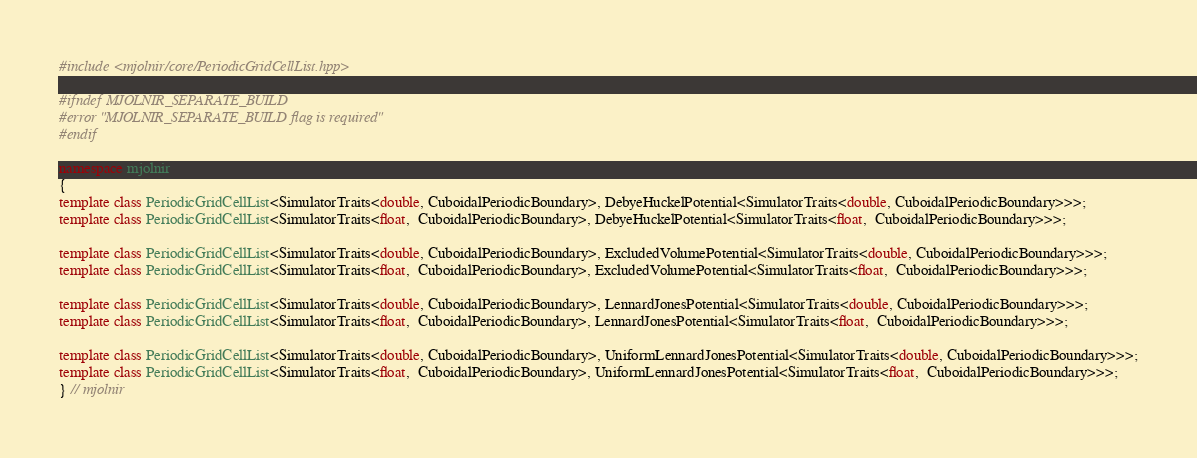<code> <loc_0><loc_0><loc_500><loc_500><_C++_>#include <mjolnir/core/PeriodicGridCellList.hpp>

#ifndef MJOLNIR_SEPARATE_BUILD
#error "MJOLNIR_SEPARATE_BUILD flag is required"
#endif

namespace mjolnir
{
template class PeriodicGridCellList<SimulatorTraits<double, CuboidalPeriodicBoundary>, DebyeHuckelPotential<SimulatorTraits<double, CuboidalPeriodicBoundary>>>;
template class PeriodicGridCellList<SimulatorTraits<float,  CuboidalPeriodicBoundary>, DebyeHuckelPotential<SimulatorTraits<float,  CuboidalPeriodicBoundary>>>;

template class PeriodicGridCellList<SimulatorTraits<double, CuboidalPeriodicBoundary>, ExcludedVolumePotential<SimulatorTraits<double, CuboidalPeriodicBoundary>>>;
template class PeriodicGridCellList<SimulatorTraits<float,  CuboidalPeriodicBoundary>, ExcludedVolumePotential<SimulatorTraits<float,  CuboidalPeriodicBoundary>>>;

template class PeriodicGridCellList<SimulatorTraits<double, CuboidalPeriodicBoundary>, LennardJonesPotential<SimulatorTraits<double, CuboidalPeriodicBoundary>>>;
template class PeriodicGridCellList<SimulatorTraits<float,  CuboidalPeriodicBoundary>, LennardJonesPotential<SimulatorTraits<float,  CuboidalPeriodicBoundary>>>;

template class PeriodicGridCellList<SimulatorTraits<double, CuboidalPeriodicBoundary>, UniformLennardJonesPotential<SimulatorTraits<double, CuboidalPeriodicBoundary>>>;
template class PeriodicGridCellList<SimulatorTraits<float,  CuboidalPeriodicBoundary>, UniformLennardJonesPotential<SimulatorTraits<float,  CuboidalPeriodicBoundary>>>;
} // mjolnir
</code> 